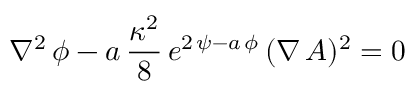Convert formula to latex. <formula><loc_0><loc_0><loc_500><loc_500>\nabla ^ { 2 } \, \phi - a \, { \frac { \kappa ^ { 2 } } { 8 } } \, e ^ { 2 \, \psi - a \, \phi } \, ( \nabla \, A ) ^ { 2 } = 0</formula> 